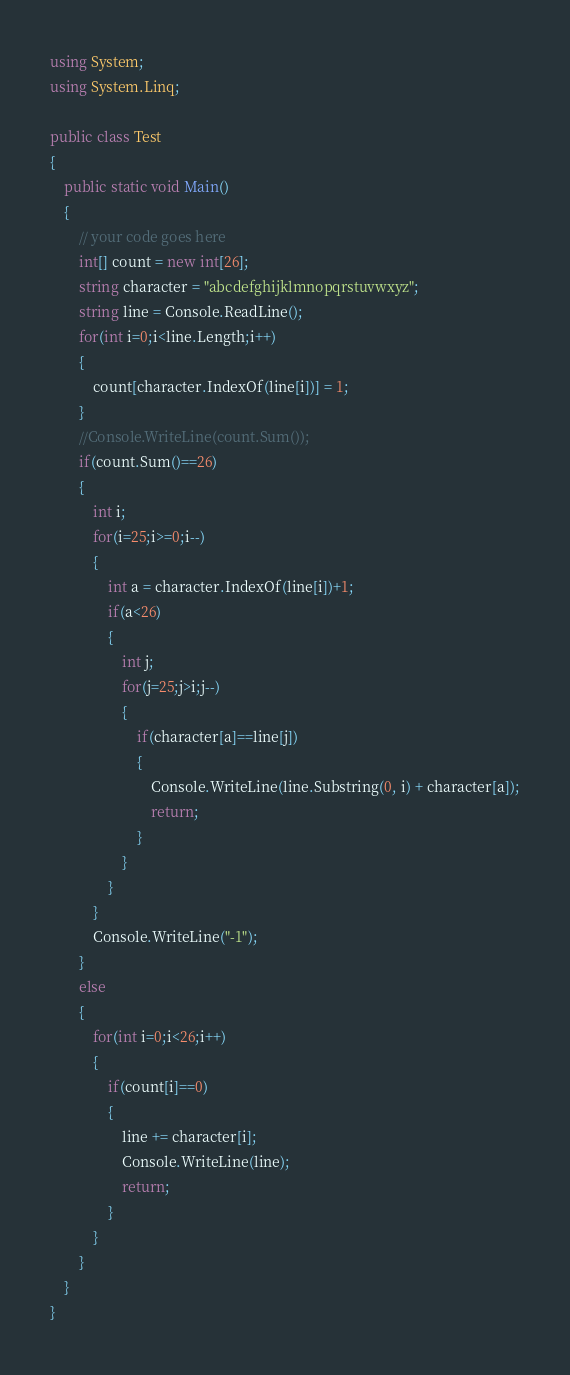<code> <loc_0><loc_0><loc_500><loc_500><_C#_>using System;
using System.Linq;
 
public class Test
{
	public static void Main()
	{
		// your code goes here
		int[] count = new int[26];
		string character = "abcdefghijklmnopqrstuvwxyz";
		string line = Console.ReadLine();
		for(int i=0;i<line.Length;i++)
		{
			count[character.IndexOf(line[i])] = 1;
		}
		//Console.WriteLine(count.Sum());
		if(count.Sum()==26)
		{
			int i;
			for(i=25;i>=0;i--)
			{
				int a = character.IndexOf(line[i])+1;
				if(a<26)
				{
					int j;
					for(j=25;j>i;j--)
					{
						if(character[a]==line[j])
						{
							Console.WriteLine(line.Substring(0, i) + character[a]);
							return;
						}
					}
				}
			}
			Console.WriteLine("-1");
		}
		else
		{
			for(int i=0;i<26;i++)
			{
				if(count[i]==0)
				{
					line += character[i];
					Console.WriteLine(line);
					return;
				}
			}
		}
	}
}
</code> 